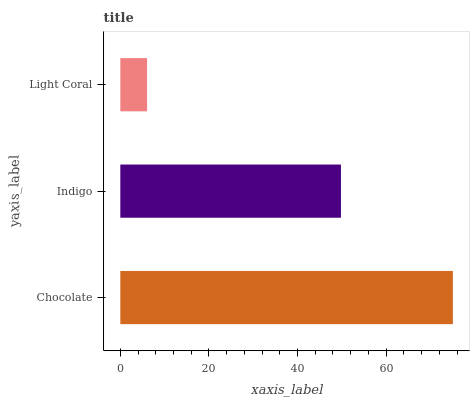Is Light Coral the minimum?
Answer yes or no. Yes. Is Chocolate the maximum?
Answer yes or no. Yes. Is Indigo the minimum?
Answer yes or no. No. Is Indigo the maximum?
Answer yes or no. No. Is Chocolate greater than Indigo?
Answer yes or no. Yes. Is Indigo less than Chocolate?
Answer yes or no. Yes. Is Indigo greater than Chocolate?
Answer yes or no. No. Is Chocolate less than Indigo?
Answer yes or no. No. Is Indigo the high median?
Answer yes or no. Yes. Is Indigo the low median?
Answer yes or no. Yes. Is Chocolate the high median?
Answer yes or no. No. Is Chocolate the low median?
Answer yes or no. No. 